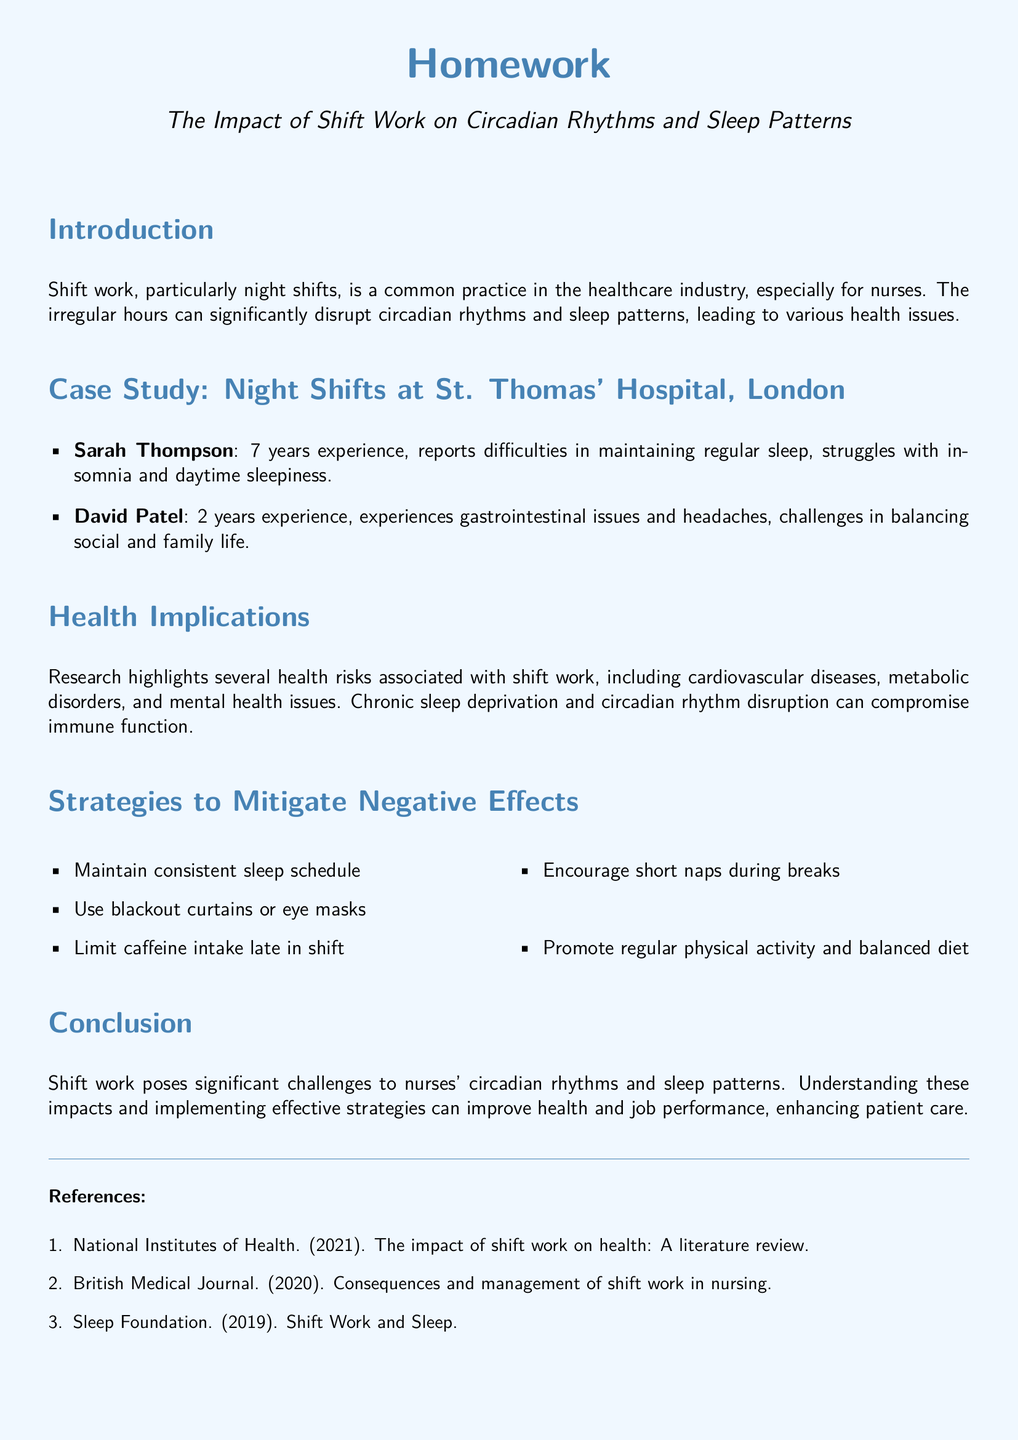What is the title of the homework? The title of the homework is presented at the beginning of the document, which relates to shift work and its effects.
Answer: The Impact of Shift Work on Circadian Rhythms and Sleep Patterns How many years of experience does Sarah Thompson have? Sarah Thompson's experience is mentioned in the case study section, stating the number of years directly.
Answer: 7 years What health risks are associated with shift work? The health implications section lists risks linked to shift work and their impact on physical and mental health.
Answer: Cardiovascular diseases What strategy is suggested to mitigate the negative effects of shift work? Several strategies are mentioned to help mitigate the adverse effects of shift work on health and sleep.
Answer: Maintain consistent sleep schedule Which case study participant reports insomnia? The document identifies which case study participant experiences specific health issues related to their work shifts.
Answer: Sarah Thompson What type of document is this? The document serves a specific educational purpose as indicated in the title and introductory content.
Answer: Homework Which year was the literature review on the impact of shift work published by the National Institutes of Health? The reference section includes the year along with the authorship for citation purposes.
Answer: 2021 